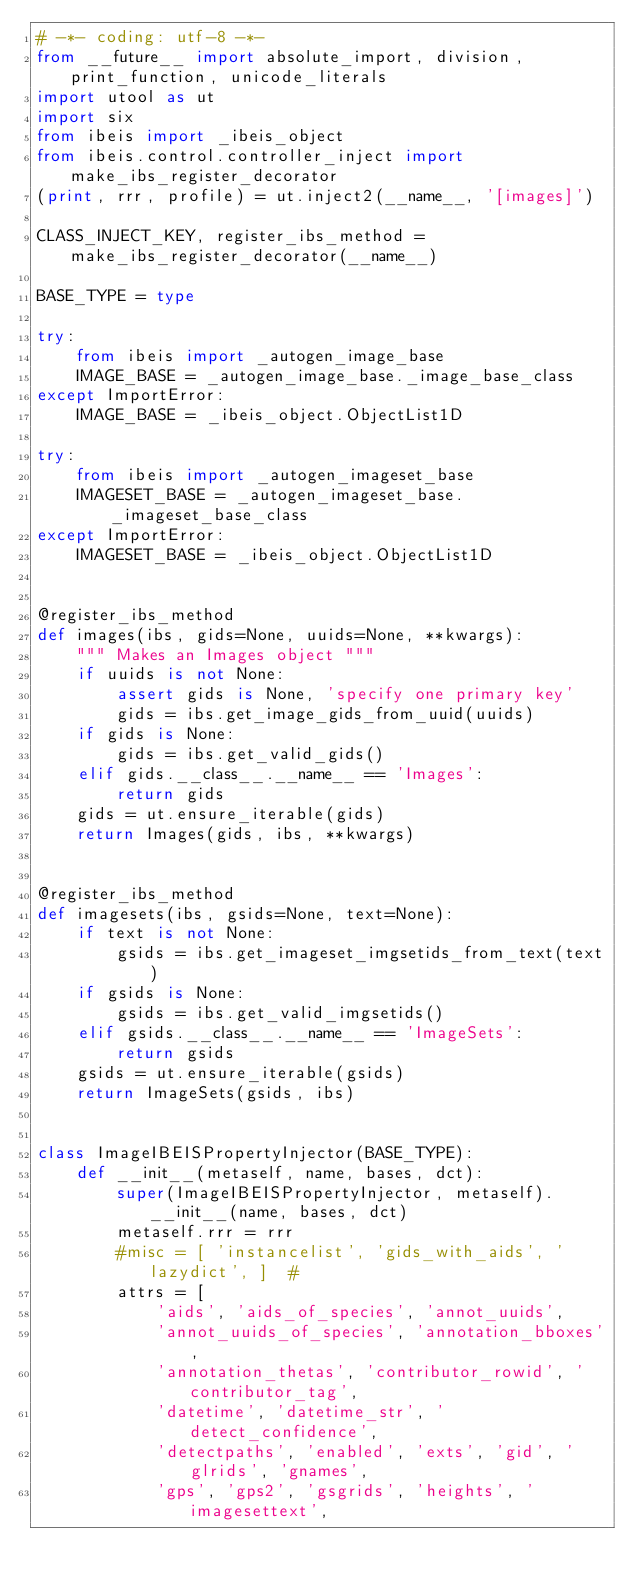Convert code to text. <code><loc_0><loc_0><loc_500><loc_500><_Python_># -*- coding: utf-8 -*-
from __future__ import absolute_import, division, print_function, unicode_literals
import utool as ut
import six
from ibeis import _ibeis_object
from ibeis.control.controller_inject import make_ibs_register_decorator
(print, rrr, profile) = ut.inject2(__name__, '[images]')

CLASS_INJECT_KEY, register_ibs_method = make_ibs_register_decorator(__name__)

BASE_TYPE = type

try:
    from ibeis import _autogen_image_base
    IMAGE_BASE = _autogen_image_base._image_base_class
except ImportError:
    IMAGE_BASE = _ibeis_object.ObjectList1D

try:
    from ibeis import _autogen_imageset_base
    IMAGESET_BASE = _autogen_imageset_base._imageset_base_class
except ImportError:
    IMAGESET_BASE = _ibeis_object.ObjectList1D


@register_ibs_method
def images(ibs, gids=None, uuids=None, **kwargs):
    """ Makes an Images object """
    if uuids is not None:
        assert gids is None, 'specify one primary key'
        gids = ibs.get_image_gids_from_uuid(uuids)
    if gids is None:
        gids = ibs.get_valid_gids()
    elif gids.__class__.__name__ == 'Images':
        return gids
    gids = ut.ensure_iterable(gids)
    return Images(gids, ibs, **kwargs)


@register_ibs_method
def imagesets(ibs, gsids=None, text=None):
    if text is not None:
        gsids = ibs.get_imageset_imgsetids_from_text(text)
    if gsids is None:
        gsids = ibs.get_valid_imgsetids()
    elif gsids.__class__.__name__ == 'ImageSets':
        return gsids
    gsids = ut.ensure_iterable(gsids)
    return ImageSets(gsids, ibs)


class ImageIBEISPropertyInjector(BASE_TYPE):
    def __init__(metaself, name, bases, dct):
        super(ImageIBEISPropertyInjector, metaself).__init__(name, bases, dct)
        metaself.rrr = rrr
        #misc = [ 'instancelist', 'gids_with_aids', 'lazydict', ]  #
        attrs = [
            'aids', 'aids_of_species', 'annot_uuids',
            'annot_uuids_of_species', 'annotation_bboxes',
            'annotation_thetas', 'contributor_rowid', 'contributor_tag',
            'datetime', 'datetime_str', 'detect_confidence',
            'detectpaths', 'enabled', 'exts', 'gid', 'glrids', 'gnames',
            'gps', 'gps2', 'gsgrids', 'heights', 'imagesettext',</code> 